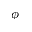Convert formula to latex. <formula><loc_0><loc_0><loc_500><loc_500>\phi</formula> 